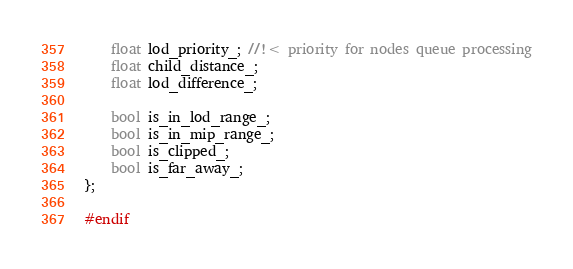<code> <loc_0><loc_0><loc_500><loc_500><_C_>
	float lod_priority_; //!< priority for nodes queue processing
	float child_distance_;
	float lod_difference_;

	bool is_in_lod_range_;
	bool is_in_mip_range_;
	bool is_clipped_;
	bool is_far_away_;
};

#endif</code> 